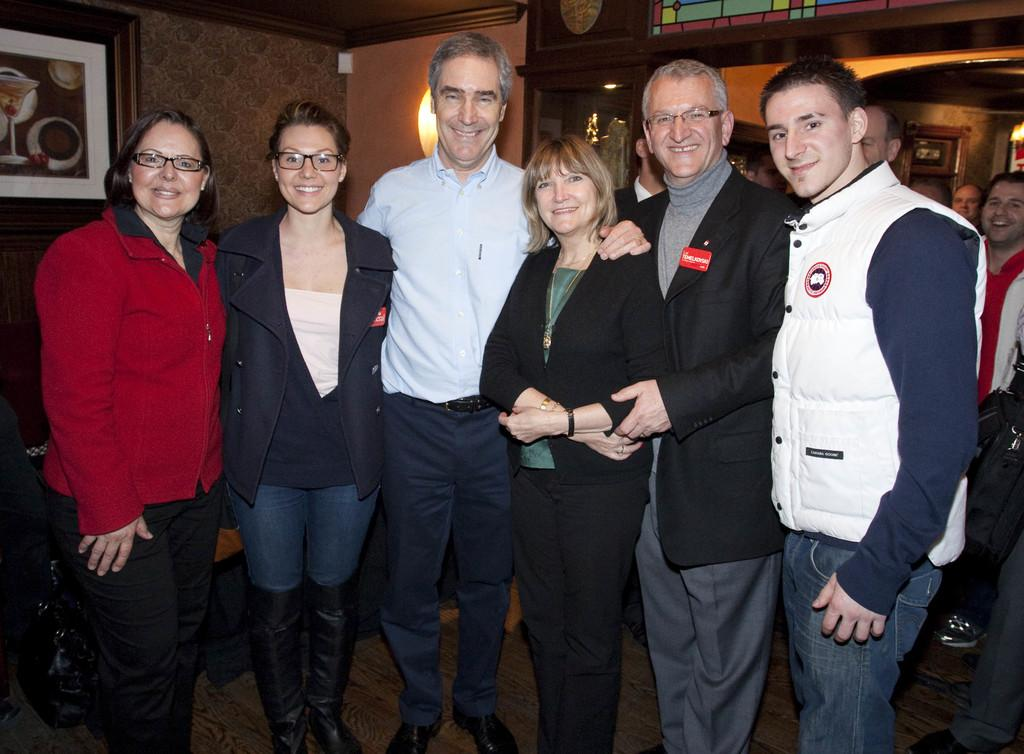What can be observed about the people in the image? There are people standing in the image, and some of them are wearing spectacles. How are the people feeling in the image? The people have smiles on their faces, indicating that they are happy or enjoying themselves. What is present on the wall in the image? There is a photo frame on the wall in the image. What can be seen in terms of lighting in the image? There is lighting visible in the image, which suggests that the scene is well-lit. Can you tell me how many dolls are sitting on the rod in the image? There are no dolls or rods present in the image. What type of frog can be seen jumping in the background of the image? There is no frog visible in the image; it only features people standing and smiling. 